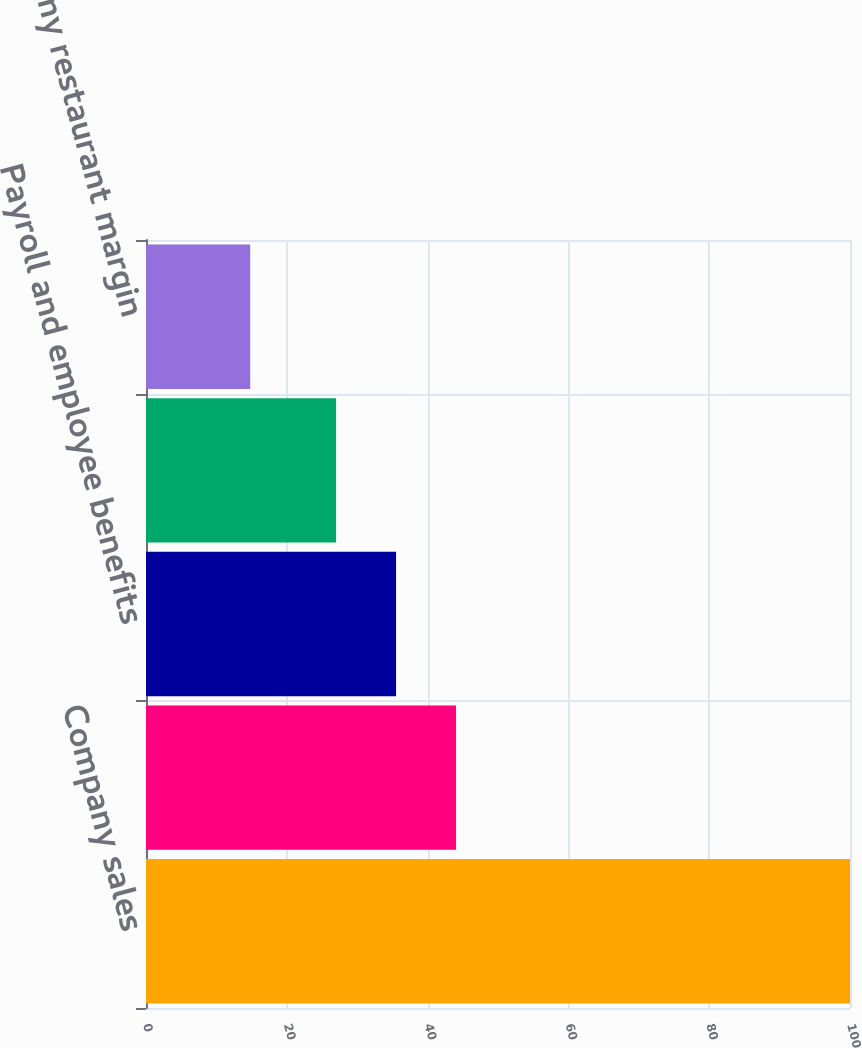<chart> <loc_0><loc_0><loc_500><loc_500><bar_chart><fcel>Company sales<fcel>Food and paper<fcel>Payroll and employee benefits<fcel>Occupancy and other operating<fcel>Company restaurant margin<nl><fcel>100<fcel>44.04<fcel>35.52<fcel>27<fcel>14.8<nl></chart> 